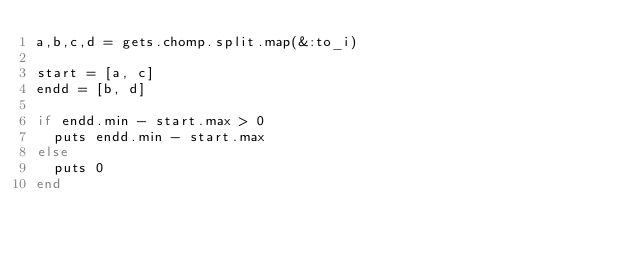Convert code to text. <code><loc_0><loc_0><loc_500><loc_500><_Ruby_>a,b,c,d = gets.chomp.split.map(&:to_i)

start = [a, c]
endd = [b, d]

if endd.min - start.max > 0
  puts endd.min - start.max
else
  puts 0
end
</code> 